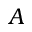<formula> <loc_0><loc_0><loc_500><loc_500>A</formula> 